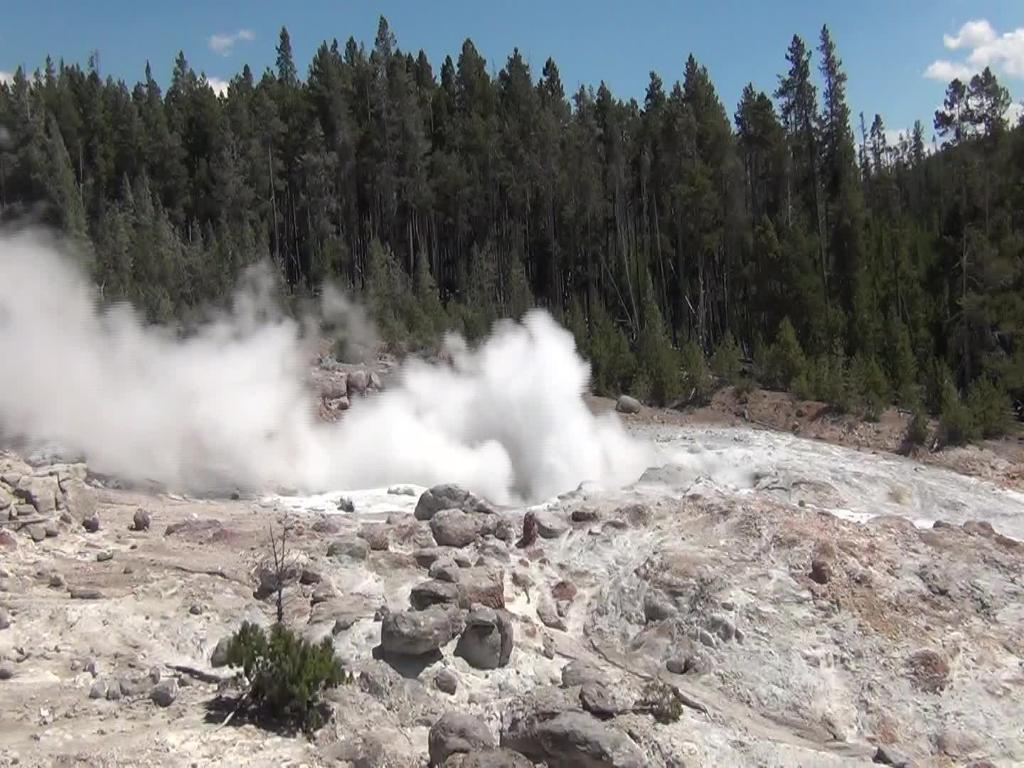What type of natural elements can be seen in the image? There are trees, plants, and rocks visible in the image. What kind of landscape is depicted in the image? The image appears to depict a hill. Is there any indication of human activity in the image? There is a possible smoke visible in the image, which could be a sign of human activity. Can you see any icicles hanging from the trees in the image? There are no icicles visible in the image. How many bananas are being waved in the good-bye scene in the image? There is no good-bye scene or bananas present in the image. 